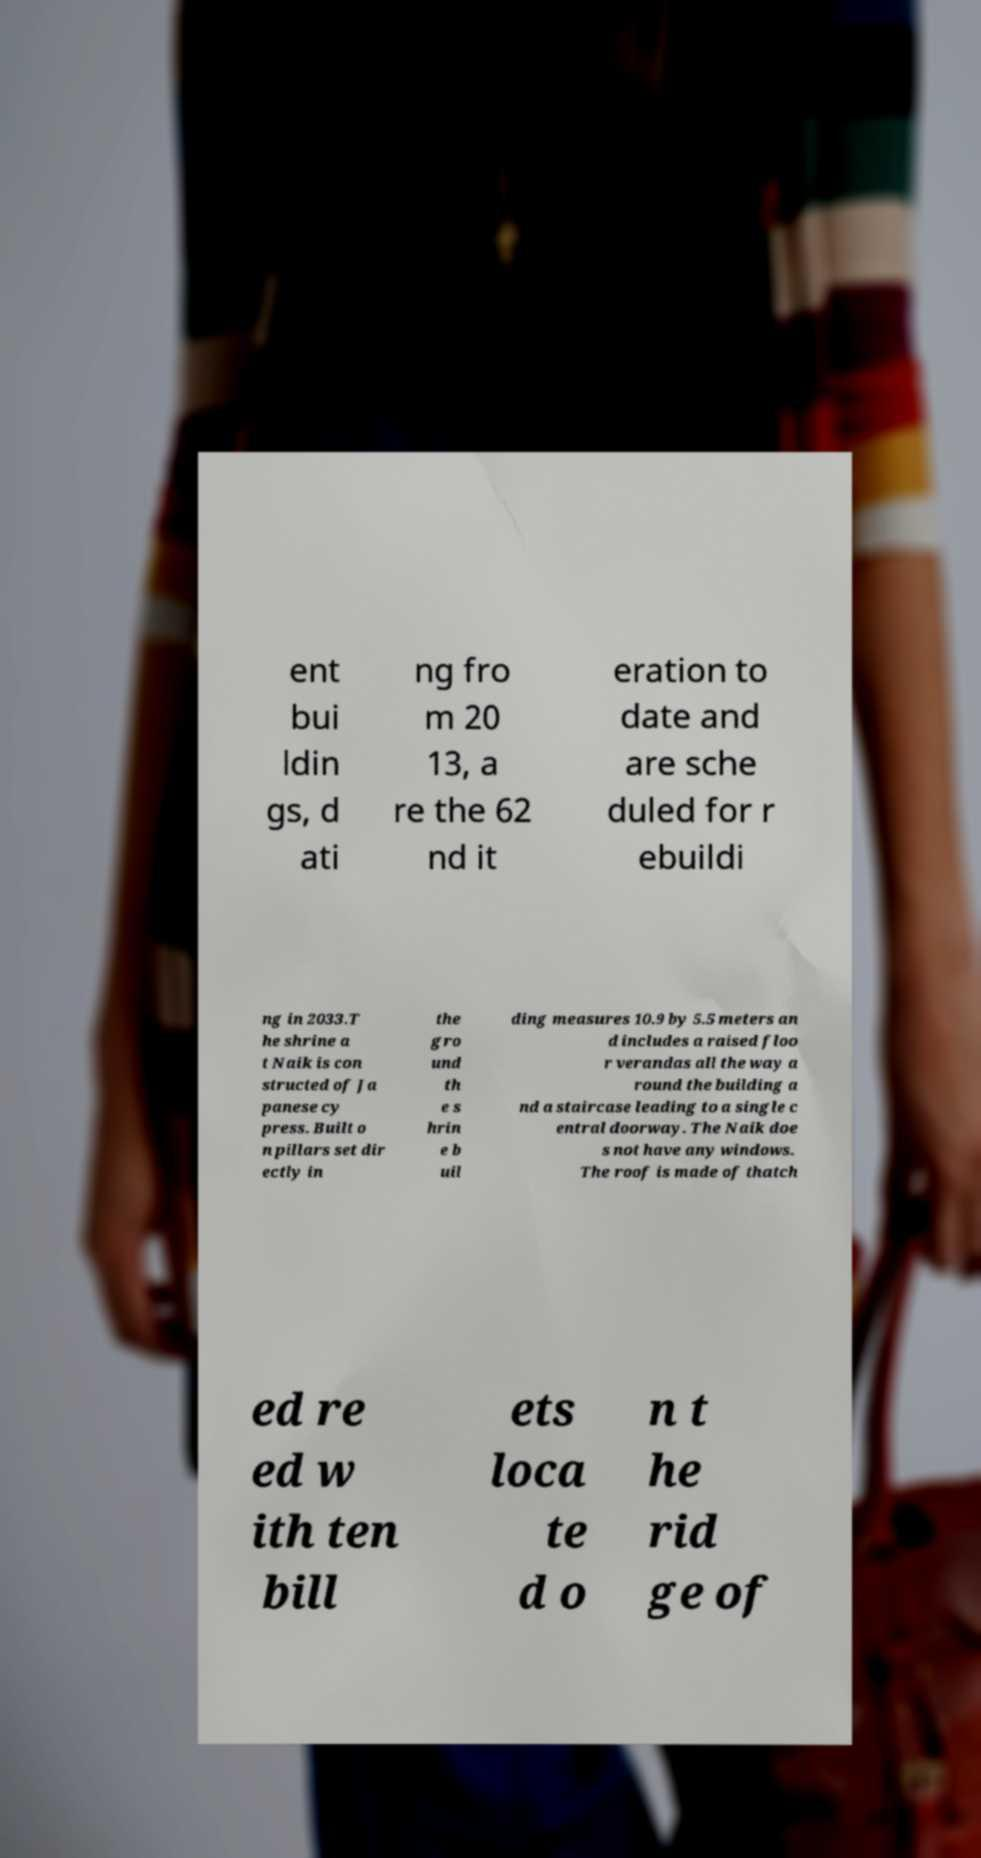For documentation purposes, I need the text within this image transcribed. Could you provide that? ent bui ldin gs, d ati ng fro m 20 13, a re the 62 nd it eration to date and are sche duled for r ebuildi ng in 2033.T he shrine a t Naik is con structed of Ja panese cy press. Built o n pillars set dir ectly in the gro und th e s hrin e b uil ding measures 10.9 by 5.5 meters an d includes a raised floo r verandas all the way a round the building a nd a staircase leading to a single c entral doorway. The Naik doe s not have any windows. The roof is made of thatch ed re ed w ith ten bill ets loca te d o n t he rid ge of 